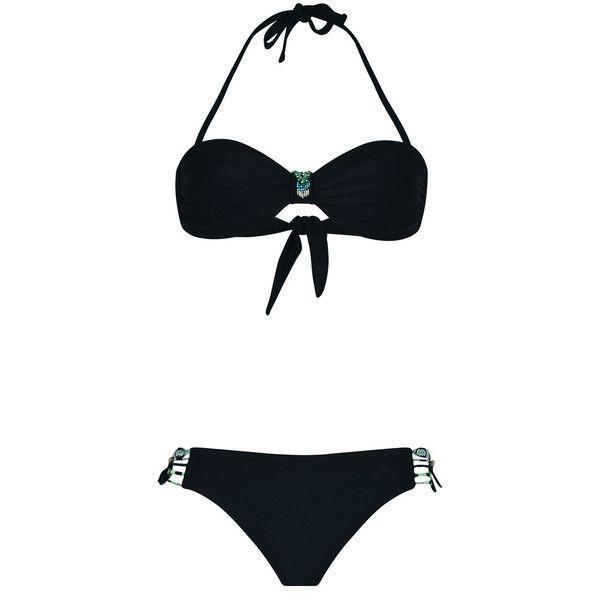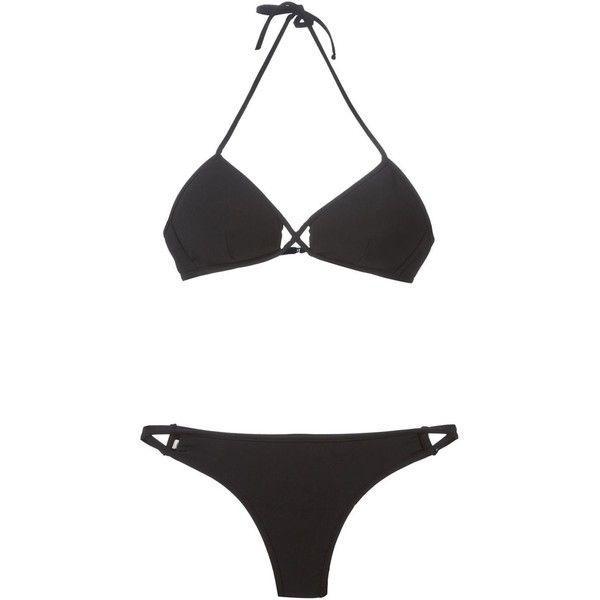The first image is the image on the left, the second image is the image on the right. Given the left and right images, does the statement "Both swimsuits are primarily black in color" hold true? Answer yes or no. Yes. 